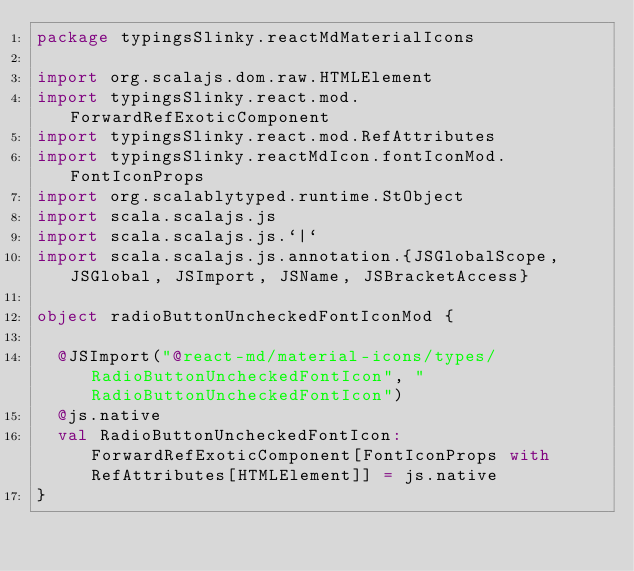<code> <loc_0><loc_0><loc_500><loc_500><_Scala_>package typingsSlinky.reactMdMaterialIcons

import org.scalajs.dom.raw.HTMLElement
import typingsSlinky.react.mod.ForwardRefExoticComponent
import typingsSlinky.react.mod.RefAttributes
import typingsSlinky.reactMdIcon.fontIconMod.FontIconProps
import org.scalablytyped.runtime.StObject
import scala.scalajs.js
import scala.scalajs.js.`|`
import scala.scalajs.js.annotation.{JSGlobalScope, JSGlobal, JSImport, JSName, JSBracketAccess}

object radioButtonUncheckedFontIconMod {
  
  @JSImport("@react-md/material-icons/types/RadioButtonUncheckedFontIcon", "RadioButtonUncheckedFontIcon")
  @js.native
  val RadioButtonUncheckedFontIcon: ForwardRefExoticComponent[FontIconProps with RefAttributes[HTMLElement]] = js.native
}
</code> 